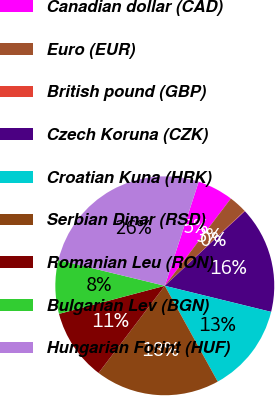Convert chart. <chart><loc_0><loc_0><loc_500><loc_500><pie_chart><fcel>Canadian dollar (CAD)<fcel>Euro (EUR)<fcel>British pound (GBP)<fcel>Czech Koruna (CZK)<fcel>Croatian Kuna (HRK)<fcel>Serbian Dinar (RSD)<fcel>Romanian Leu (RON)<fcel>Bulgarian Lev (BGN)<fcel>Hungarian Forint (HUF)<nl><fcel>5.3%<fcel>2.69%<fcel>0.07%<fcel>15.76%<fcel>13.14%<fcel>18.37%<fcel>10.53%<fcel>7.92%<fcel>26.22%<nl></chart> 